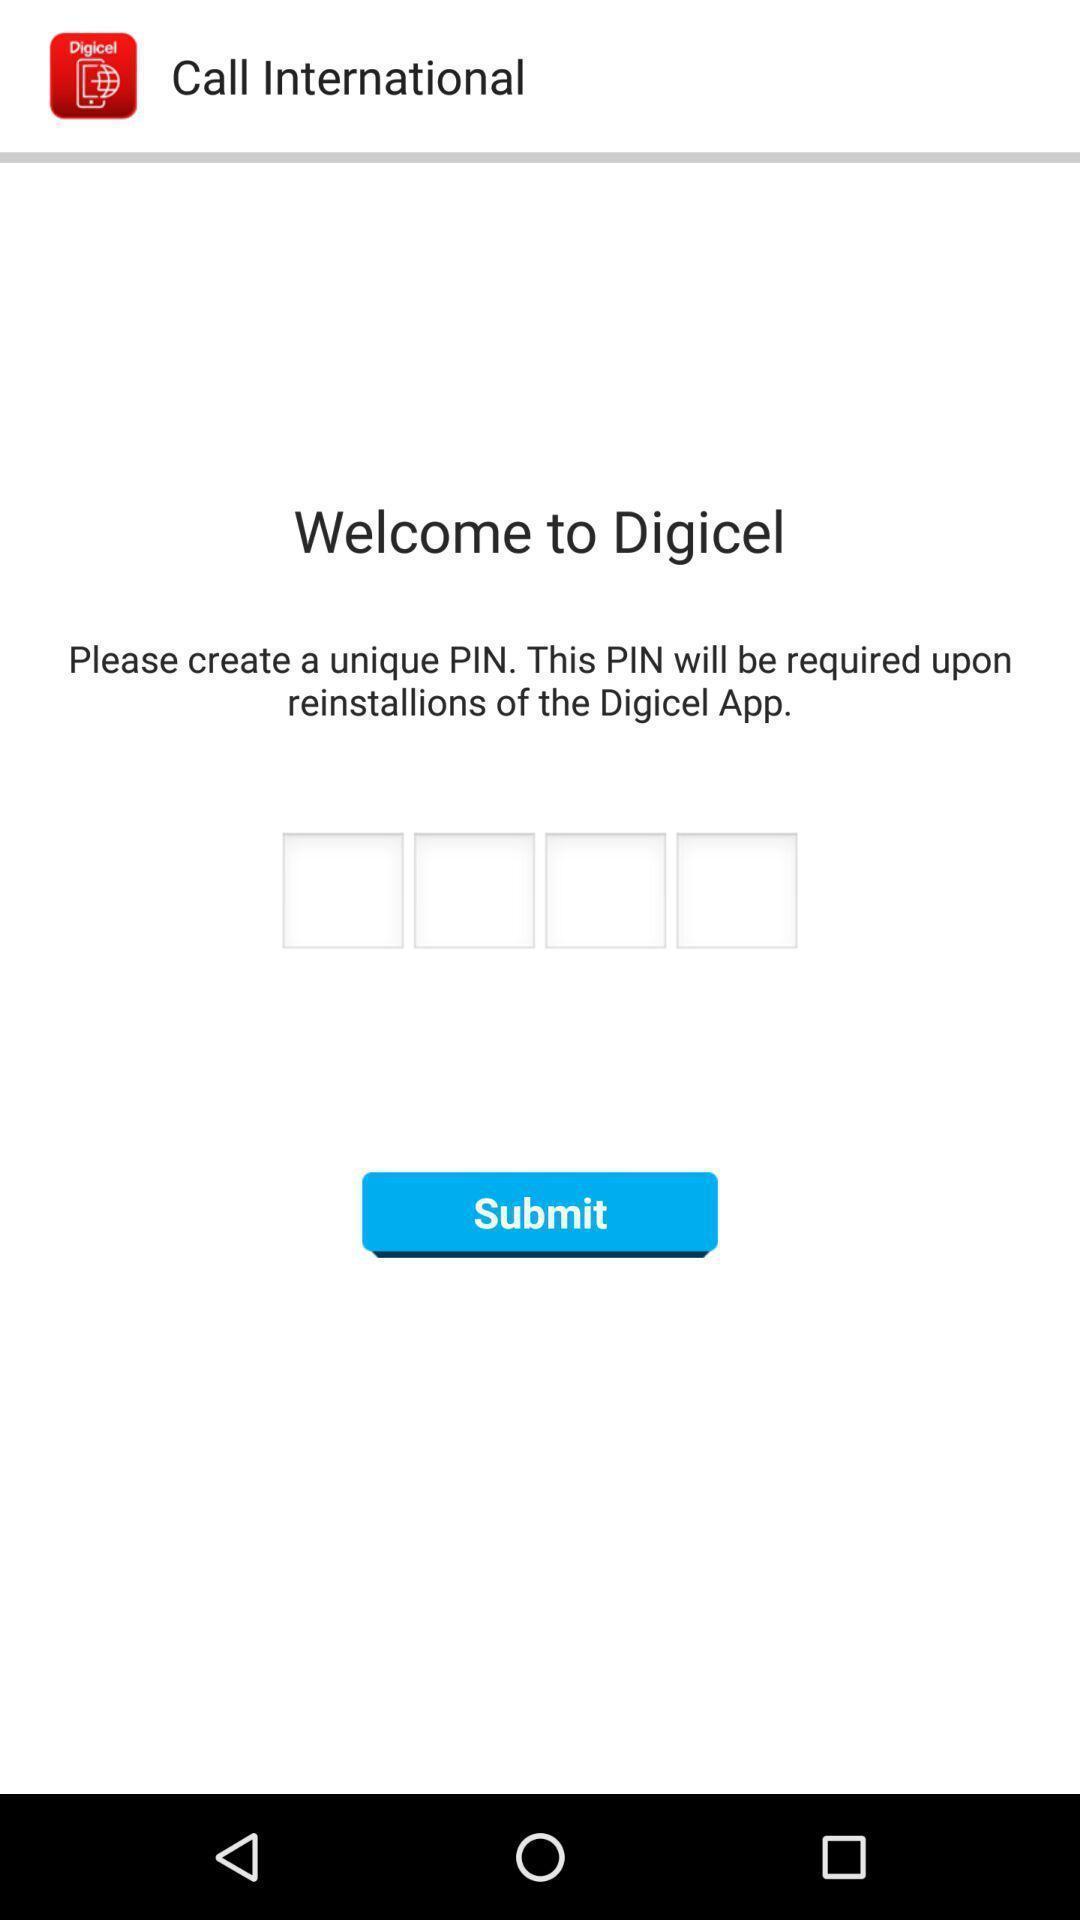Summarize the main components in this picture. Window asking to create a pin. 